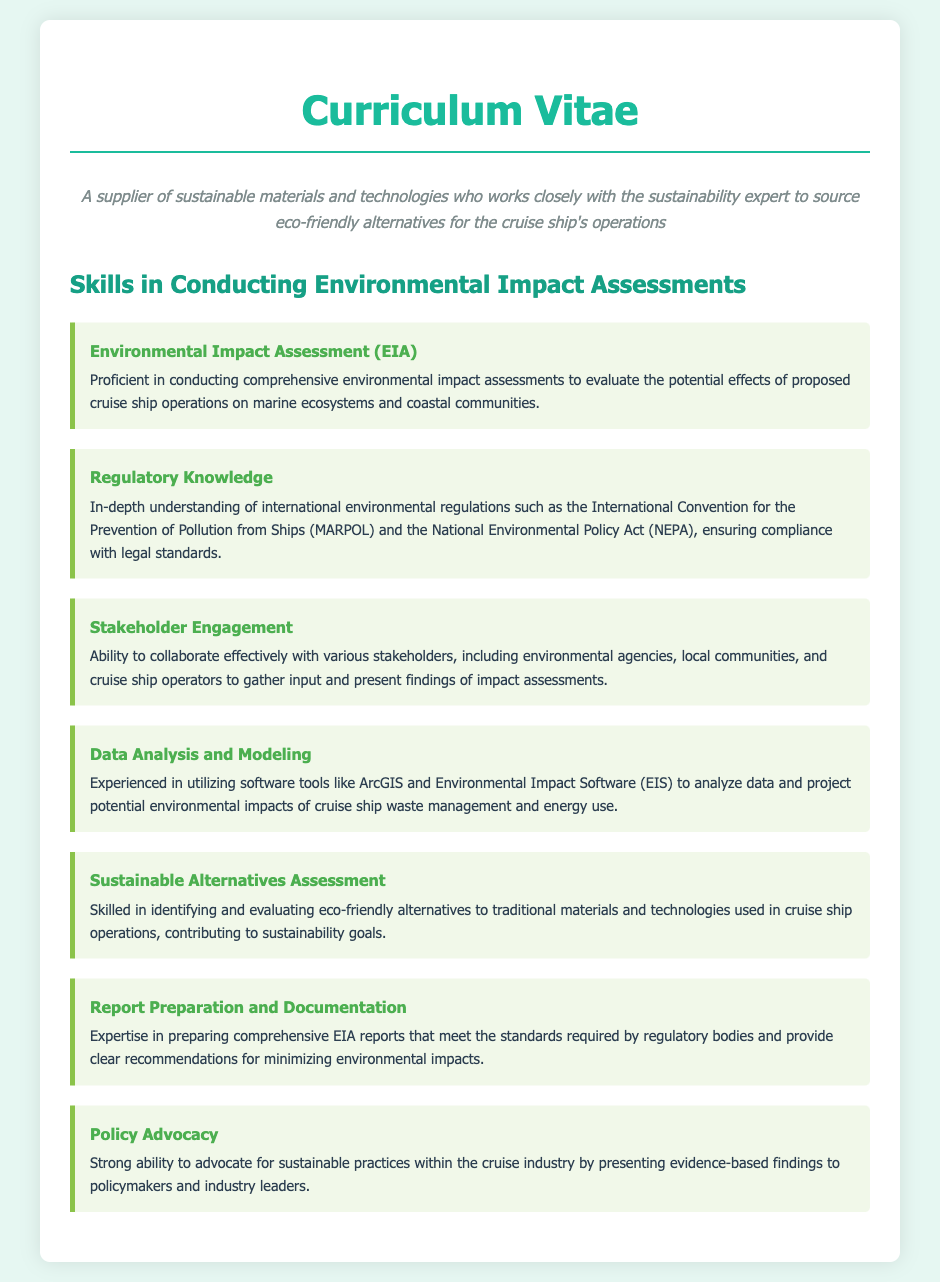What is the title of the document? The title of the document is indicated at the top of the CV.
Answer: Curriculum Vitae What skill involves evaluating effects on marine ecosystems? This skill is described under the specific skill related to conducting assessments for cruise ship operations.
Answer: Environmental Impact Assessment (EIA) Which international convention is referenced for regulatory knowledge? The international convention mentioned focuses on pollution prevention specifically for ships.
Answer: MARPOL What software tools are mentioned for data analysis? The document lists specific software tools used for analyzing environmental impacts.
Answer: ArcGIS and Environmental Impact Software (EIS) What is emphasized in the skill of Stakeholder Engagement? The ability described here pertains to collaboration with different groups related to cruise ship operations.
Answer: Collaborate effectively What type of reports does the individual prepare? The document notes the specific kind of reports prepared in relation to environmental assessments.
Answer: EIA reports How is policy advocacy defined in the document? This skill highlights the ability to influence decision-makers based on evidence.
Answer: Presenting evidence-based findings What is one of the main objectives related to sustainable alternatives? The skill emphasizes finding alternatives to traditional materials for specific operations.
Answer: Identifying eco-friendly alternatives 